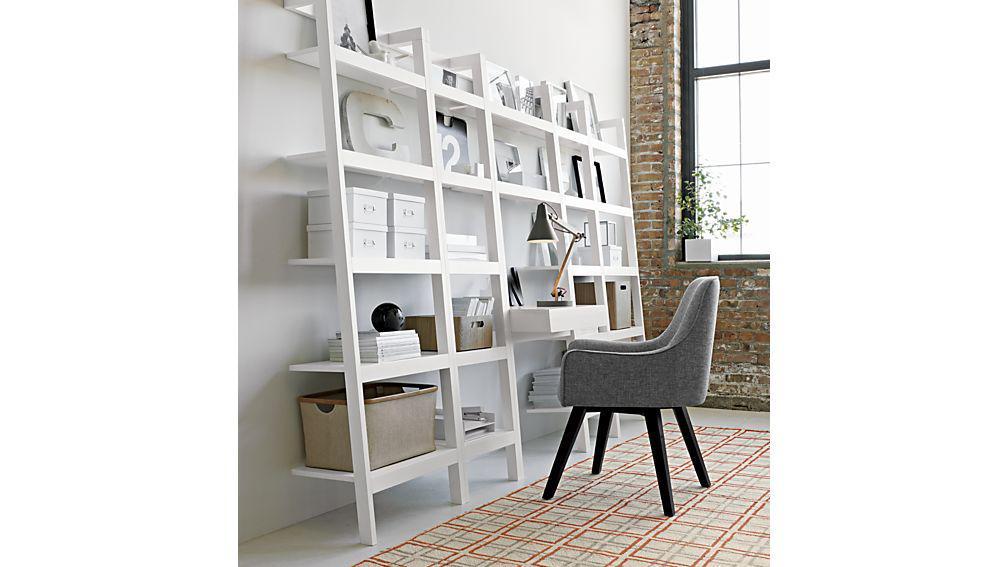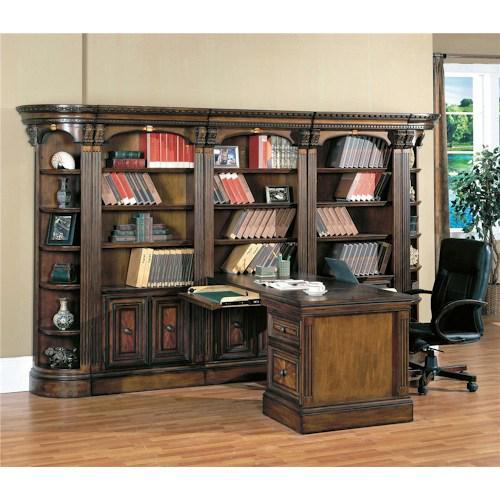The first image is the image on the left, the second image is the image on the right. Given the left and right images, does the statement "One image includes a simple gray desk with open shelves underneath and a matching slant-front set of shelves that resembles a ladder." hold true? Answer yes or no. No. The first image is the image on the left, the second image is the image on the right. Assess this claim about the two images: "In one image a leather chair is placed at a desk unit that is attached and perpendicular to a large bookcase.". Correct or not? Answer yes or no. Yes. 